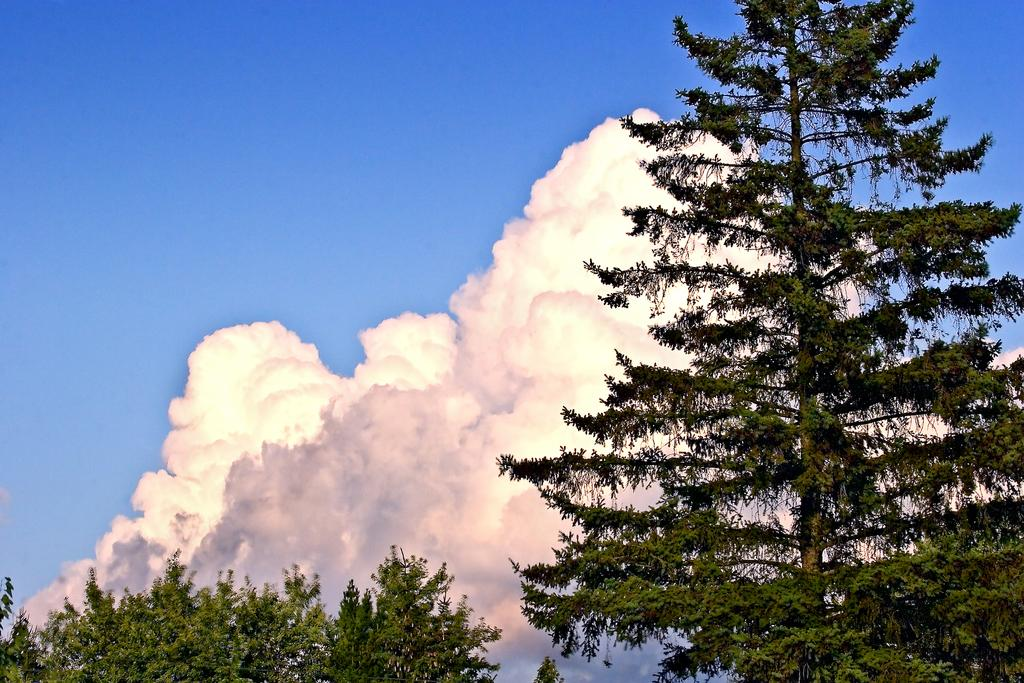What type of vegetation can be seen in the image? There are trees in the image. What part of the natural environment is visible in the image? The sky is visible in the image. What can be seen in the sky in the image? Clouds are present in the image. What type of bears can be seen interacting with the bone in the image? There are no bears or bones present in the image. What scent can be detected in the image? There is no mention of any scent in the image. 